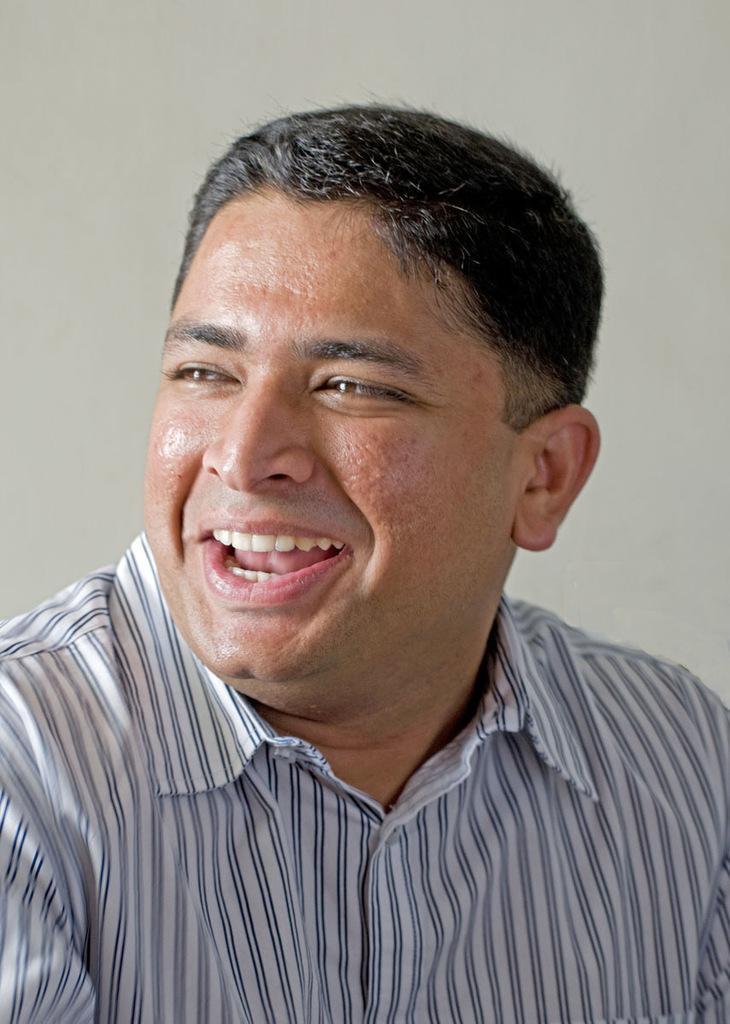Can you describe this image briefly? In this image we can see a person smiling and in the background, we can see a wall. 